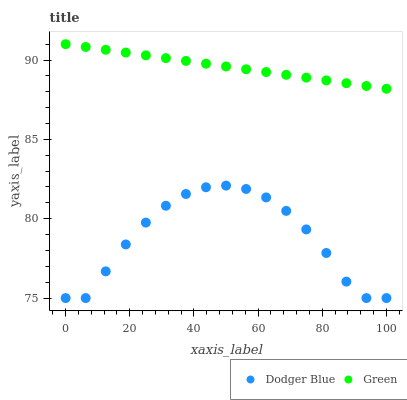Does Dodger Blue have the minimum area under the curve?
Answer yes or no. Yes. Does Green have the maximum area under the curve?
Answer yes or no. Yes. Does Dodger Blue have the maximum area under the curve?
Answer yes or no. No. Is Green the smoothest?
Answer yes or no. Yes. Is Dodger Blue the roughest?
Answer yes or no. Yes. Is Dodger Blue the smoothest?
Answer yes or no. No. Does Dodger Blue have the lowest value?
Answer yes or no. Yes. Does Green have the highest value?
Answer yes or no. Yes. Does Dodger Blue have the highest value?
Answer yes or no. No. Is Dodger Blue less than Green?
Answer yes or no. Yes. Is Green greater than Dodger Blue?
Answer yes or no. Yes. Does Dodger Blue intersect Green?
Answer yes or no. No. 